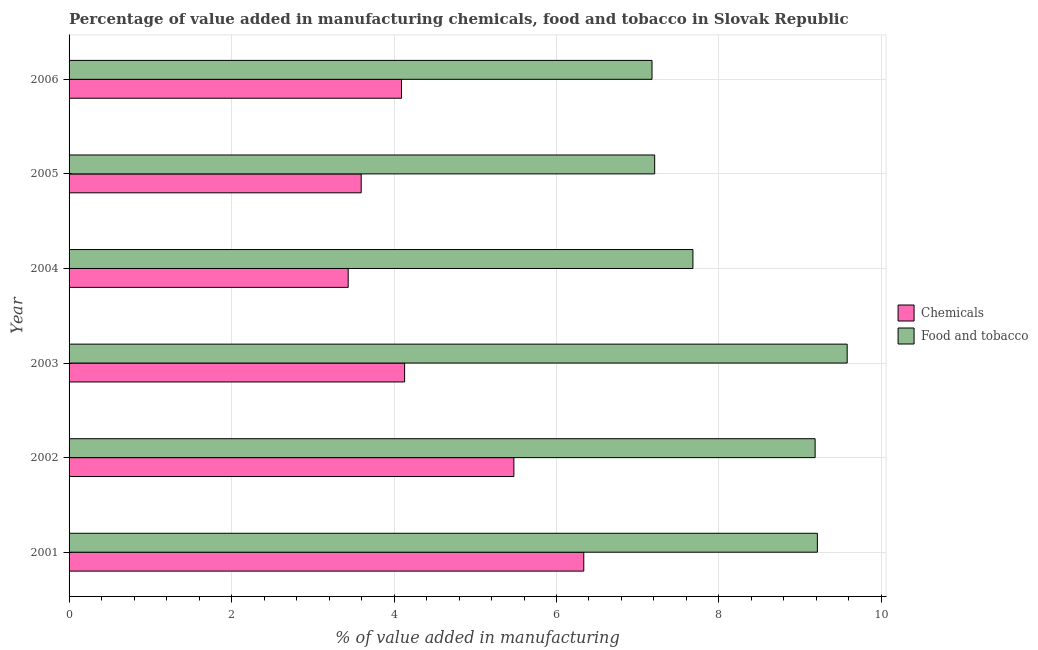Are the number of bars per tick equal to the number of legend labels?
Your response must be concise. Yes. How many bars are there on the 1st tick from the top?
Provide a short and direct response. 2. How many bars are there on the 3rd tick from the bottom?
Your response must be concise. 2. In how many cases, is the number of bars for a given year not equal to the number of legend labels?
Your answer should be very brief. 0. What is the value added by manufacturing food and tobacco in 2004?
Provide a succinct answer. 7.68. Across all years, what is the maximum value added by manufacturing food and tobacco?
Your answer should be compact. 9.58. Across all years, what is the minimum value added by manufacturing food and tobacco?
Your answer should be very brief. 7.18. What is the total value added by manufacturing food and tobacco in the graph?
Your response must be concise. 50.04. What is the difference between the value added by manufacturing food and tobacco in 2001 and that in 2006?
Ensure brevity in your answer.  2.04. What is the difference between the value added by manufacturing food and tobacco in 2005 and the value added by  manufacturing chemicals in 2003?
Give a very brief answer. 3.08. What is the average value added by manufacturing food and tobacco per year?
Provide a short and direct response. 8.34. In the year 2003, what is the difference between the value added by  manufacturing chemicals and value added by manufacturing food and tobacco?
Provide a short and direct response. -5.45. In how many years, is the value added by manufacturing food and tobacco greater than 0.8 %?
Offer a terse response. 6. What is the ratio of the value added by  manufacturing chemicals in 2004 to that in 2005?
Provide a short and direct response. 0.96. What is the difference between the highest and the second highest value added by manufacturing food and tobacco?
Ensure brevity in your answer.  0.37. What is the difference between the highest and the lowest value added by  manufacturing chemicals?
Your answer should be compact. 2.9. In how many years, is the value added by manufacturing food and tobacco greater than the average value added by manufacturing food and tobacco taken over all years?
Give a very brief answer. 3. What does the 2nd bar from the top in 2003 represents?
Give a very brief answer. Chemicals. What does the 1st bar from the bottom in 2003 represents?
Give a very brief answer. Chemicals. How many bars are there?
Provide a short and direct response. 12. Are all the bars in the graph horizontal?
Give a very brief answer. Yes. How many years are there in the graph?
Your response must be concise. 6. Are the values on the major ticks of X-axis written in scientific E-notation?
Provide a succinct answer. No. Does the graph contain any zero values?
Offer a terse response. No. Where does the legend appear in the graph?
Keep it short and to the point. Center right. How many legend labels are there?
Your answer should be compact. 2. What is the title of the graph?
Make the answer very short. Percentage of value added in manufacturing chemicals, food and tobacco in Slovak Republic. What is the label or title of the X-axis?
Provide a succinct answer. % of value added in manufacturing. What is the label or title of the Y-axis?
Your answer should be very brief. Year. What is the % of value added in manufacturing in Chemicals in 2001?
Make the answer very short. 6.34. What is the % of value added in manufacturing of Food and tobacco in 2001?
Provide a succinct answer. 9.21. What is the % of value added in manufacturing in Chemicals in 2002?
Give a very brief answer. 5.48. What is the % of value added in manufacturing in Food and tobacco in 2002?
Your answer should be compact. 9.18. What is the % of value added in manufacturing in Chemicals in 2003?
Your answer should be compact. 4.13. What is the % of value added in manufacturing of Food and tobacco in 2003?
Make the answer very short. 9.58. What is the % of value added in manufacturing in Chemicals in 2004?
Your answer should be very brief. 3.44. What is the % of value added in manufacturing of Food and tobacco in 2004?
Your answer should be very brief. 7.68. What is the % of value added in manufacturing of Chemicals in 2005?
Your answer should be compact. 3.6. What is the % of value added in manufacturing in Food and tobacco in 2005?
Make the answer very short. 7.21. What is the % of value added in manufacturing of Chemicals in 2006?
Ensure brevity in your answer.  4.09. What is the % of value added in manufacturing of Food and tobacco in 2006?
Offer a very short reply. 7.18. Across all years, what is the maximum % of value added in manufacturing of Chemicals?
Offer a terse response. 6.34. Across all years, what is the maximum % of value added in manufacturing of Food and tobacco?
Your answer should be very brief. 9.58. Across all years, what is the minimum % of value added in manufacturing of Chemicals?
Give a very brief answer. 3.44. Across all years, what is the minimum % of value added in manufacturing in Food and tobacco?
Offer a very short reply. 7.18. What is the total % of value added in manufacturing in Chemicals in the graph?
Give a very brief answer. 27.07. What is the total % of value added in manufacturing in Food and tobacco in the graph?
Provide a succinct answer. 50.04. What is the difference between the % of value added in manufacturing of Chemicals in 2001 and that in 2002?
Your response must be concise. 0.86. What is the difference between the % of value added in manufacturing in Food and tobacco in 2001 and that in 2002?
Make the answer very short. 0.03. What is the difference between the % of value added in manufacturing of Chemicals in 2001 and that in 2003?
Provide a short and direct response. 2.21. What is the difference between the % of value added in manufacturing of Food and tobacco in 2001 and that in 2003?
Provide a succinct answer. -0.37. What is the difference between the % of value added in manufacturing in Chemicals in 2001 and that in 2004?
Your response must be concise. 2.9. What is the difference between the % of value added in manufacturing of Food and tobacco in 2001 and that in 2004?
Your answer should be very brief. 1.53. What is the difference between the % of value added in manufacturing of Chemicals in 2001 and that in 2005?
Offer a terse response. 2.74. What is the difference between the % of value added in manufacturing in Food and tobacco in 2001 and that in 2005?
Your answer should be very brief. 2. What is the difference between the % of value added in manufacturing of Chemicals in 2001 and that in 2006?
Keep it short and to the point. 2.24. What is the difference between the % of value added in manufacturing of Food and tobacco in 2001 and that in 2006?
Ensure brevity in your answer.  2.04. What is the difference between the % of value added in manufacturing in Chemicals in 2002 and that in 2003?
Provide a succinct answer. 1.34. What is the difference between the % of value added in manufacturing in Food and tobacco in 2002 and that in 2003?
Ensure brevity in your answer.  -0.39. What is the difference between the % of value added in manufacturing of Chemicals in 2002 and that in 2004?
Your answer should be compact. 2.04. What is the difference between the % of value added in manufacturing in Food and tobacco in 2002 and that in 2004?
Offer a very short reply. 1.5. What is the difference between the % of value added in manufacturing in Chemicals in 2002 and that in 2005?
Your answer should be very brief. 1.88. What is the difference between the % of value added in manufacturing in Food and tobacco in 2002 and that in 2005?
Keep it short and to the point. 1.98. What is the difference between the % of value added in manufacturing of Chemicals in 2002 and that in 2006?
Your answer should be compact. 1.38. What is the difference between the % of value added in manufacturing in Food and tobacco in 2002 and that in 2006?
Your answer should be very brief. 2.01. What is the difference between the % of value added in manufacturing of Chemicals in 2003 and that in 2004?
Your answer should be very brief. 0.69. What is the difference between the % of value added in manufacturing in Food and tobacco in 2003 and that in 2004?
Ensure brevity in your answer.  1.9. What is the difference between the % of value added in manufacturing of Chemicals in 2003 and that in 2005?
Provide a short and direct response. 0.53. What is the difference between the % of value added in manufacturing in Food and tobacco in 2003 and that in 2005?
Provide a short and direct response. 2.37. What is the difference between the % of value added in manufacturing of Chemicals in 2003 and that in 2006?
Your response must be concise. 0.04. What is the difference between the % of value added in manufacturing in Food and tobacco in 2003 and that in 2006?
Offer a terse response. 2.4. What is the difference between the % of value added in manufacturing of Chemicals in 2004 and that in 2005?
Your answer should be compact. -0.16. What is the difference between the % of value added in manufacturing in Food and tobacco in 2004 and that in 2005?
Offer a very short reply. 0.47. What is the difference between the % of value added in manufacturing of Chemicals in 2004 and that in 2006?
Your response must be concise. -0.66. What is the difference between the % of value added in manufacturing in Food and tobacco in 2004 and that in 2006?
Your response must be concise. 0.5. What is the difference between the % of value added in manufacturing of Chemicals in 2005 and that in 2006?
Make the answer very short. -0.5. What is the difference between the % of value added in manufacturing in Food and tobacco in 2005 and that in 2006?
Your answer should be very brief. 0.03. What is the difference between the % of value added in manufacturing in Chemicals in 2001 and the % of value added in manufacturing in Food and tobacco in 2002?
Provide a succinct answer. -2.85. What is the difference between the % of value added in manufacturing of Chemicals in 2001 and the % of value added in manufacturing of Food and tobacco in 2003?
Offer a very short reply. -3.24. What is the difference between the % of value added in manufacturing in Chemicals in 2001 and the % of value added in manufacturing in Food and tobacco in 2004?
Give a very brief answer. -1.34. What is the difference between the % of value added in manufacturing of Chemicals in 2001 and the % of value added in manufacturing of Food and tobacco in 2005?
Offer a very short reply. -0.87. What is the difference between the % of value added in manufacturing of Chemicals in 2001 and the % of value added in manufacturing of Food and tobacco in 2006?
Provide a succinct answer. -0.84. What is the difference between the % of value added in manufacturing in Chemicals in 2002 and the % of value added in manufacturing in Food and tobacco in 2003?
Ensure brevity in your answer.  -4.1. What is the difference between the % of value added in manufacturing of Chemicals in 2002 and the % of value added in manufacturing of Food and tobacco in 2004?
Give a very brief answer. -2.2. What is the difference between the % of value added in manufacturing in Chemicals in 2002 and the % of value added in manufacturing in Food and tobacco in 2005?
Your response must be concise. -1.73. What is the difference between the % of value added in manufacturing in Chemicals in 2002 and the % of value added in manufacturing in Food and tobacco in 2006?
Give a very brief answer. -1.7. What is the difference between the % of value added in manufacturing in Chemicals in 2003 and the % of value added in manufacturing in Food and tobacco in 2004?
Make the answer very short. -3.55. What is the difference between the % of value added in manufacturing in Chemicals in 2003 and the % of value added in manufacturing in Food and tobacco in 2005?
Offer a very short reply. -3.08. What is the difference between the % of value added in manufacturing of Chemicals in 2003 and the % of value added in manufacturing of Food and tobacco in 2006?
Your response must be concise. -3.05. What is the difference between the % of value added in manufacturing of Chemicals in 2004 and the % of value added in manufacturing of Food and tobacco in 2005?
Give a very brief answer. -3.77. What is the difference between the % of value added in manufacturing in Chemicals in 2004 and the % of value added in manufacturing in Food and tobacco in 2006?
Provide a succinct answer. -3.74. What is the difference between the % of value added in manufacturing in Chemicals in 2005 and the % of value added in manufacturing in Food and tobacco in 2006?
Your response must be concise. -3.58. What is the average % of value added in manufacturing of Chemicals per year?
Give a very brief answer. 4.51. What is the average % of value added in manufacturing in Food and tobacco per year?
Your response must be concise. 8.34. In the year 2001, what is the difference between the % of value added in manufacturing of Chemicals and % of value added in manufacturing of Food and tobacco?
Your answer should be very brief. -2.88. In the year 2002, what is the difference between the % of value added in manufacturing of Chemicals and % of value added in manufacturing of Food and tobacco?
Keep it short and to the point. -3.71. In the year 2003, what is the difference between the % of value added in manufacturing in Chemicals and % of value added in manufacturing in Food and tobacco?
Your answer should be compact. -5.45. In the year 2004, what is the difference between the % of value added in manufacturing of Chemicals and % of value added in manufacturing of Food and tobacco?
Provide a succinct answer. -4.24. In the year 2005, what is the difference between the % of value added in manufacturing in Chemicals and % of value added in manufacturing in Food and tobacco?
Provide a succinct answer. -3.61. In the year 2006, what is the difference between the % of value added in manufacturing in Chemicals and % of value added in manufacturing in Food and tobacco?
Make the answer very short. -3.08. What is the ratio of the % of value added in manufacturing of Chemicals in 2001 to that in 2002?
Provide a succinct answer. 1.16. What is the ratio of the % of value added in manufacturing of Chemicals in 2001 to that in 2003?
Make the answer very short. 1.53. What is the ratio of the % of value added in manufacturing in Food and tobacco in 2001 to that in 2003?
Make the answer very short. 0.96. What is the ratio of the % of value added in manufacturing in Chemicals in 2001 to that in 2004?
Offer a very short reply. 1.84. What is the ratio of the % of value added in manufacturing in Food and tobacco in 2001 to that in 2004?
Keep it short and to the point. 1.2. What is the ratio of the % of value added in manufacturing in Chemicals in 2001 to that in 2005?
Offer a very short reply. 1.76. What is the ratio of the % of value added in manufacturing of Food and tobacco in 2001 to that in 2005?
Your answer should be very brief. 1.28. What is the ratio of the % of value added in manufacturing in Chemicals in 2001 to that in 2006?
Give a very brief answer. 1.55. What is the ratio of the % of value added in manufacturing of Food and tobacco in 2001 to that in 2006?
Make the answer very short. 1.28. What is the ratio of the % of value added in manufacturing in Chemicals in 2002 to that in 2003?
Your answer should be compact. 1.33. What is the ratio of the % of value added in manufacturing in Food and tobacco in 2002 to that in 2003?
Offer a very short reply. 0.96. What is the ratio of the % of value added in manufacturing in Chemicals in 2002 to that in 2004?
Offer a very short reply. 1.59. What is the ratio of the % of value added in manufacturing of Food and tobacco in 2002 to that in 2004?
Offer a terse response. 1.2. What is the ratio of the % of value added in manufacturing in Chemicals in 2002 to that in 2005?
Ensure brevity in your answer.  1.52. What is the ratio of the % of value added in manufacturing in Food and tobacco in 2002 to that in 2005?
Your answer should be compact. 1.27. What is the ratio of the % of value added in manufacturing of Chemicals in 2002 to that in 2006?
Give a very brief answer. 1.34. What is the ratio of the % of value added in manufacturing of Food and tobacco in 2002 to that in 2006?
Ensure brevity in your answer.  1.28. What is the ratio of the % of value added in manufacturing in Chemicals in 2003 to that in 2004?
Make the answer very short. 1.2. What is the ratio of the % of value added in manufacturing in Food and tobacco in 2003 to that in 2004?
Ensure brevity in your answer.  1.25. What is the ratio of the % of value added in manufacturing of Chemicals in 2003 to that in 2005?
Your answer should be very brief. 1.15. What is the ratio of the % of value added in manufacturing of Food and tobacco in 2003 to that in 2005?
Ensure brevity in your answer.  1.33. What is the ratio of the % of value added in manufacturing of Chemicals in 2003 to that in 2006?
Give a very brief answer. 1.01. What is the ratio of the % of value added in manufacturing in Food and tobacco in 2003 to that in 2006?
Your response must be concise. 1.33. What is the ratio of the % of value added in manufacturing of Chemicals in 2004 to that in 2005?
Make the answer very short. 0.96. What is the ratio of the % of value added in manufacturing in Food and tobacco in 2004 to that in 2005?
Your answer should be compact. 1.07. What is the ratio of the % of value added in manufacturing of Chemicals in 2004 to that in 2006?
Keep it short and to the point. 0.84. What is the ratio of the % of value added in manufacturing of Food and tobacco in 2004 to that in 2006?
Offer a very short reply. 1.07. What is the ratio of the % of value added in manufacturing of Chemicals in 2005 to that in 2006?
Your answer should be compact. 0.88. What is the ratio of the % of value added in manufacturing in Food and tobacco in 2005 to that in 2006?
Your answer should be very brief. 1. What is the difference between the highest and the second highest % of value added in manufacturing of Chemicals?
Ensure brevity in your answer.  0.86. What is the difference between the highest and the second highest % of value added in manufacturing of Food and tobacco?
Your response must be concise. 0.37. What is the difference between the highest and the lowest % of value added in manufacturing in Chemicals?
Your answer should be very brief. 2.9. What is the difference between the highest and the lowest % of value added in manufacturing in Food and tobacco?
Your response must be concise. 2.4. 